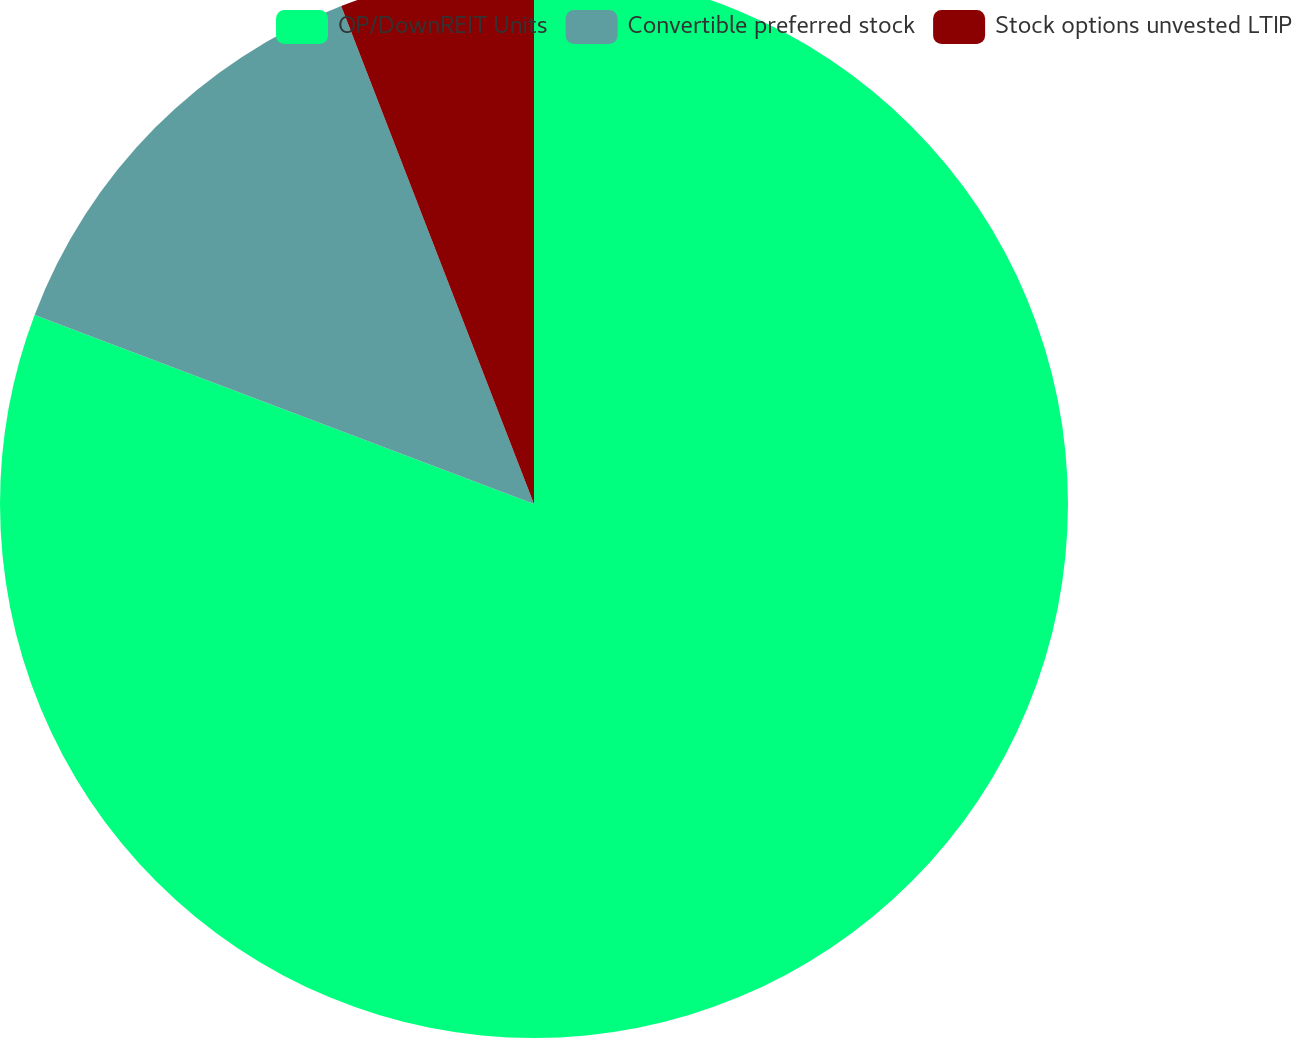<chart> <loc_0><loc_0><loc_500><loc_500><pie_chart><fcel>OP/DownREIT Units<fcel>Convertible preferred stock<fcel>Stock options unvested LTIP<nl><fcel>80.76%<fcel>13.36%<fcel>5.88%<nl></chart> 